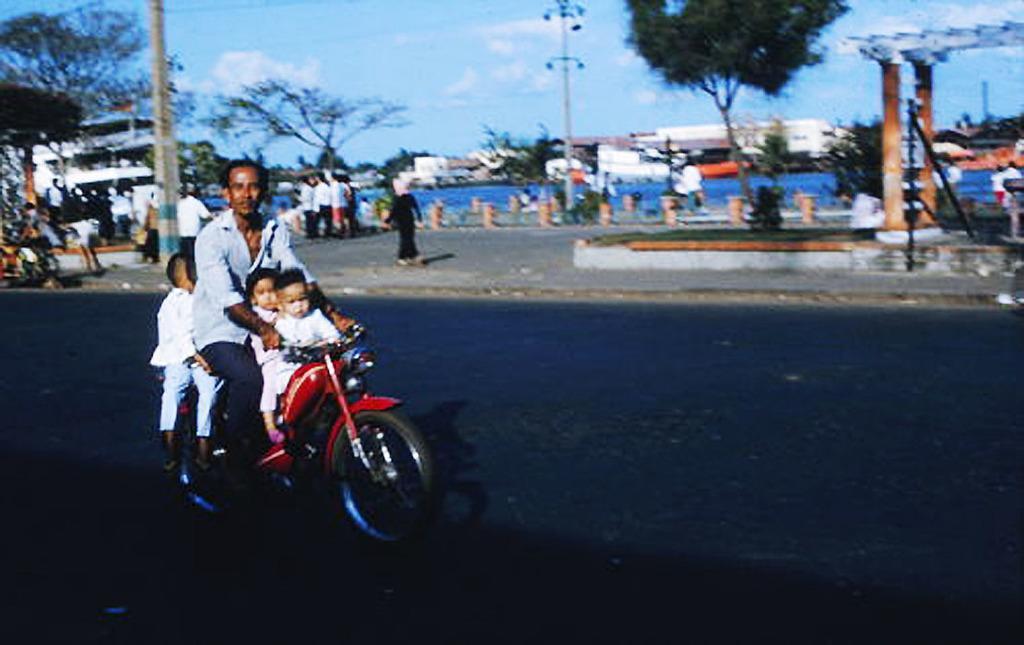Can you describe this image briefly? There is a person with three kids are riding a motorcycle on the road. On the side of the road many persons are standing. A lady is walking. Also there are some buildings, poles. In the background there is a clear sky, trees. 